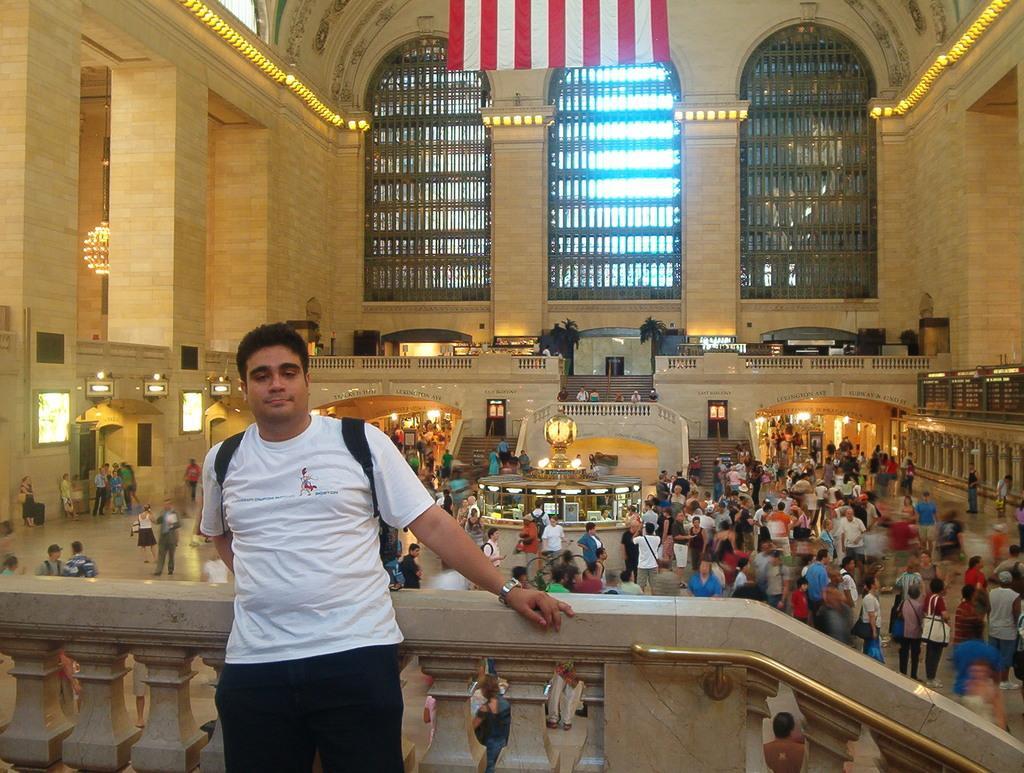Please provide a concise description of this image. Here we can see a man posing to a camera. In the background we can see group of people, lights, screens, doors, flag, pillars, and wall. 